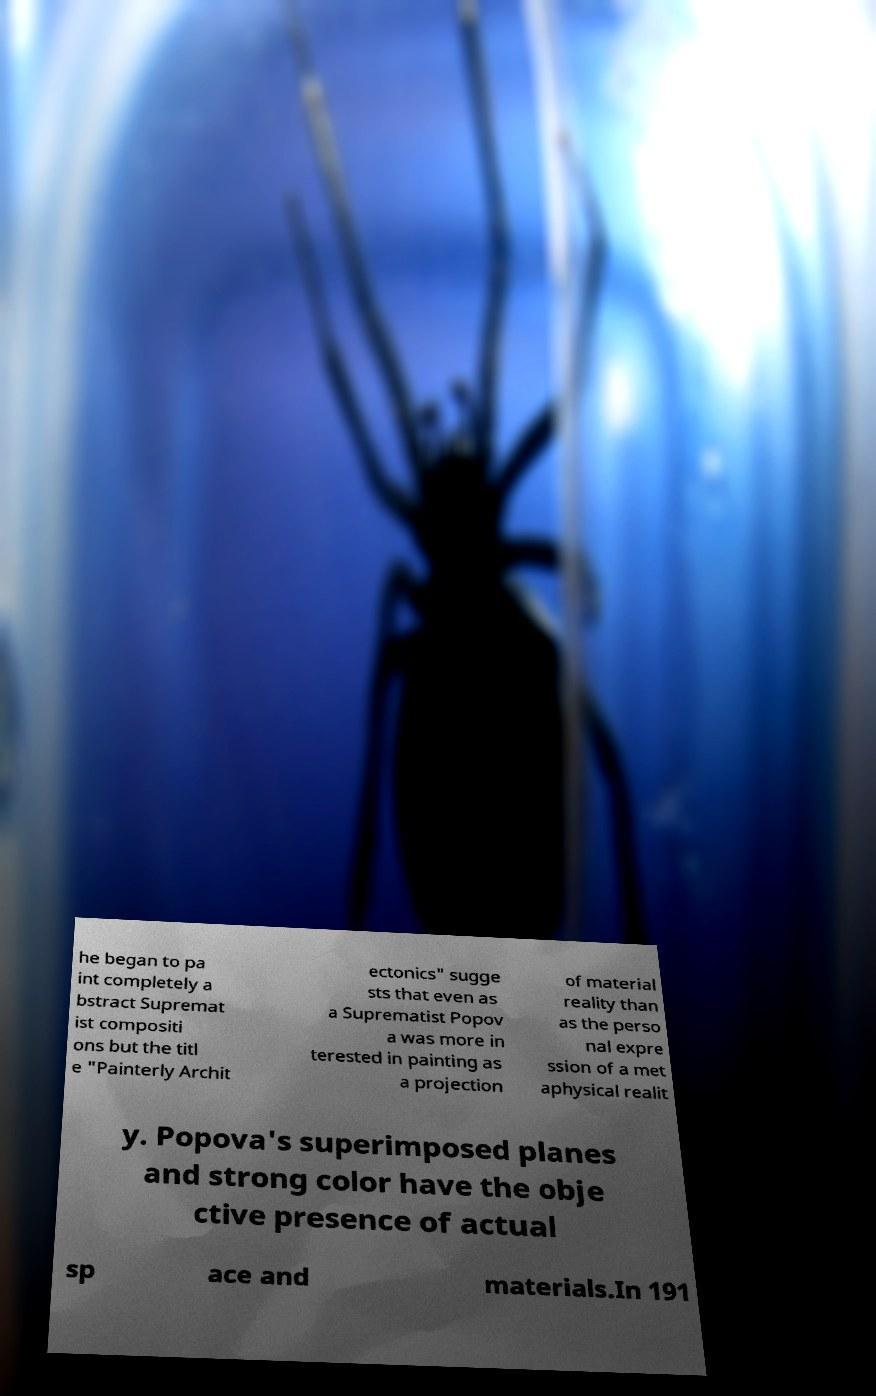Can you accurately transcribe the text from the provided image for me? he began to pa int completely a bstract Supremat ist compositi ons but the titl e "Painterly Archit ectonics" sugge sts that even as a Suprematist Popov a was more in terested in painting as a projection of material reality than as the perso nal expre ssion of a met aphysical realit y. Popova's superimposed planes and strong color have the obje ctive presence of actual sp ace and materials.In 191 